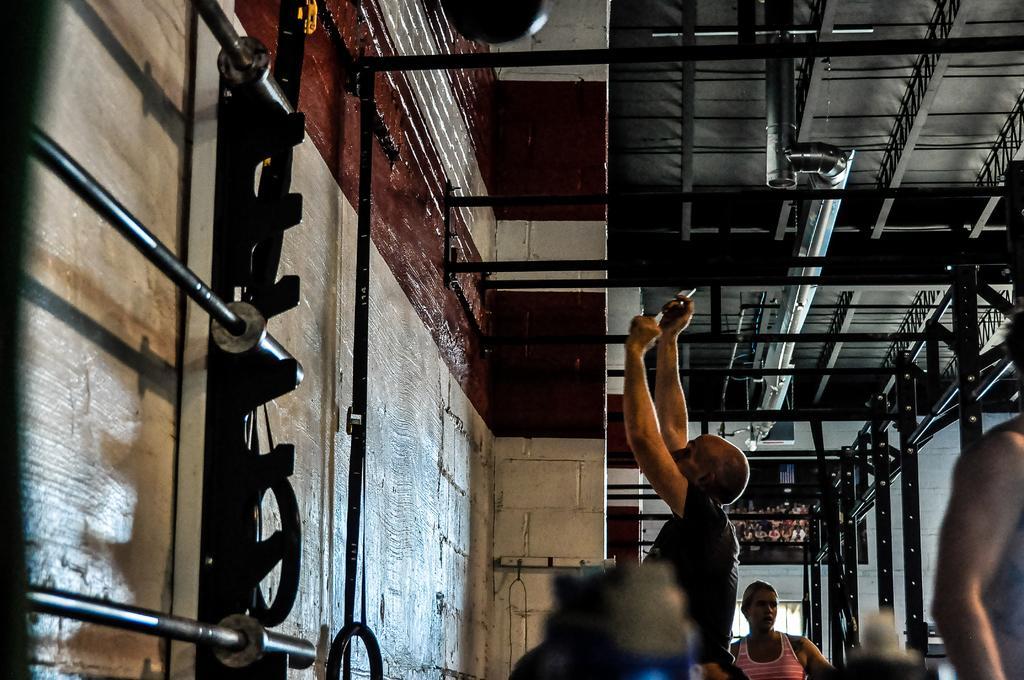Could you give a brief overview of what you see in this image? In this picture I can see 3 persons in front and I see number of rods and I can also see the walls. On the top of this picture I can see the ceiling. 